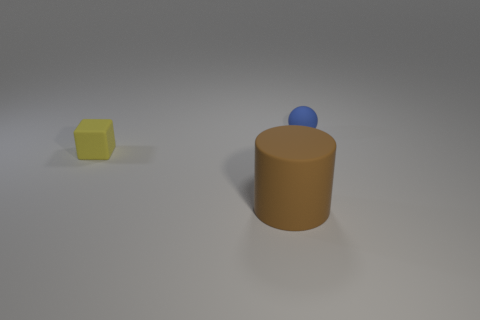Add 1 tiny blue metal objects. How many objects exist? 4 Subtract all spheres. How many objects are left? 2 Subtract all yellow blocks. Subtract all blue rubber objects. How many objects are left? 1 Add 3 big brown cylinders. How many big brown cylinders are left? 4 Add 3 large things. How many large things exist? 4 Subtract 0 blue cylinders. How many objects are left? 3 